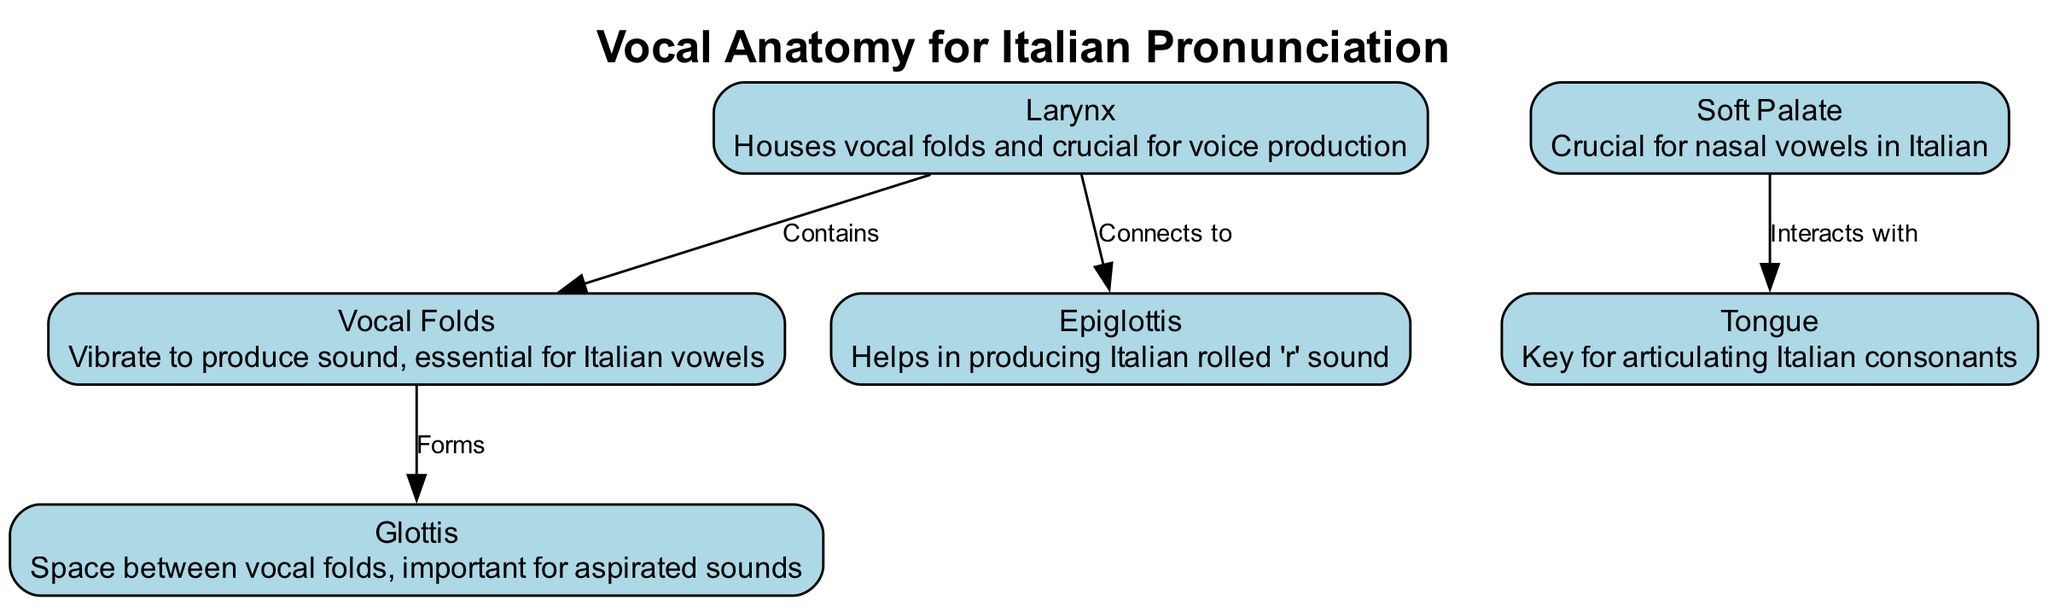What is the title of the diagram? The title is explicitly labeled at the top of the diagram as "Vocal Anatomy for Italian Pronunciation."
Answer: Vocal Anatomy for Italian Pronunciation How many nodes are in the diagram? By counting the listed nodes in the data, there are six nodes, including the larynx, vocal folds, glottis, epiglottis, soft palate, and tongue.
Answer: 6 What does the larynx contain? The edge from the "larynx" to "vocal folds" is labeled "Contains," indicating that the larynx houses the vocal folds.
Answer: Vocal Folds What is the function of the glottis? The description for the glottis says it is the "space between vocal folds," which is significant for aspirated sounds, indicating its function.
Answer: Important for aspirated sounds Which structure helps produce the Italian rolled 'r' sound? The edge connecting the "larynx" and "epiglottis" informs us that the epiglottis aids in producing this specific sound.
Answer: Epiglottis How does the soft palate interact with the tongue? The edge labeled "Interacts with" between "soft palate" and "tongue" implies a functional relationship, indicating they work together in speech production.
Answer: Interacts Which function is crucial for nasal vowels in Italian? The description of the "soft palate" states it is "crucial for nasal vowels in Italian," highlighting its importance in this context.
Answer: Nasal vowels What forms the glottis? The edge from "vocal folds" to "glottis" labeled "Forms" indicates that the glottis is created by these folds.
Answer: Vocal Folds Which part of the anatomy is key for articulating Italian consonants? The description for "tongue" specifies that it is "key for articulating Italian consonants."
Answer: Tongue 